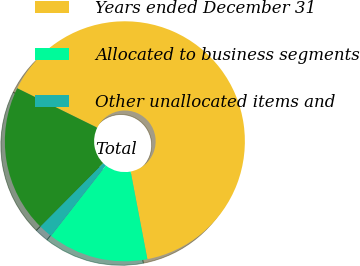Convert chart to OTSL. <chart><loc_0><loc_0><loc_500><loc_500><pie_chart><fcel>Years ended December 31<fcel>Allocated to business segments<fcel>Other unallocated items and<fcel>Total<nl><fcel>64.71%<fcel>13.55%<fcel>1.9%<fcel>19.84%<nl></chart> 